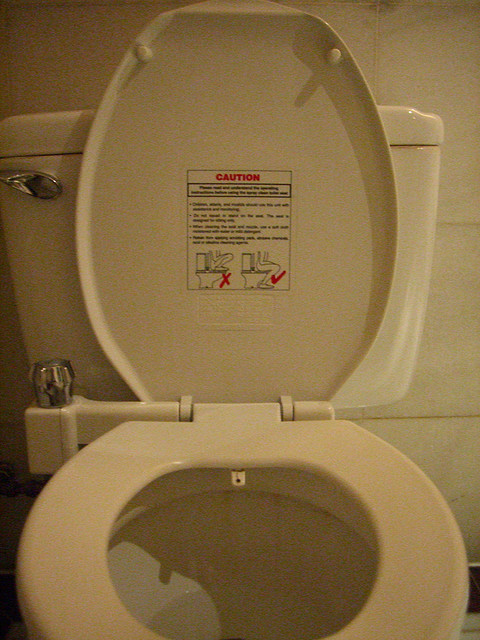<image>What letters are on the bottom sticker? It's unclear what letters are on the bottom sticker. It can be 'caution' or 'xyz'. What letters are on the bottom sticker? I don't know what letters are on the bottom sticker. It can be seen 'caution', 'english letters', 'many' or 'xyz'. 